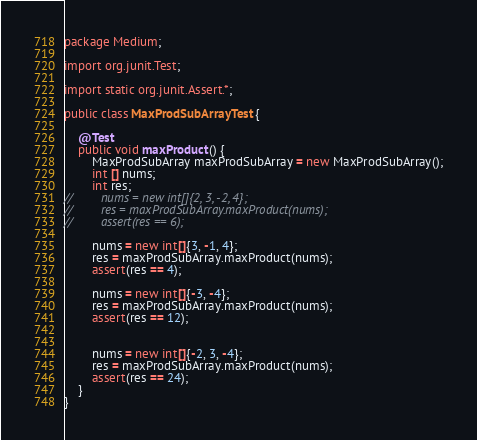Convert code to text. <code><loc_0><loc_0><loc_500><loc_500><_Java_>package Medium;

import org.junit.Test;

import static org.junit.Assert.*;

public class MaxProdSubArrayTest {

    @Test
    public void maxProduct() {
        MaxProdSubArray maxProdSubArray = new MaxProdSubArray();
        int [] nums;
        int res;
//        nums = new int[]{2, 3, -2, 4};
//        res = maxProdSubArray.maxProduct(nums);
//        assert(res == 6);

        nums = new int[]{3, -1, 4};
        res = maxProdSubArray.maxProduct(nums);
        assert(res == 4);

        nums = new int[]{-3, -4};
        res = maxProdSubArray.maxProduct(nums);
        assert(res == 12);


        nums = new int[]{-2, 3, -4};
        res = maxProdSubArray.maxProduct(nums);
        assert(res == 24);
    }
}</code> 